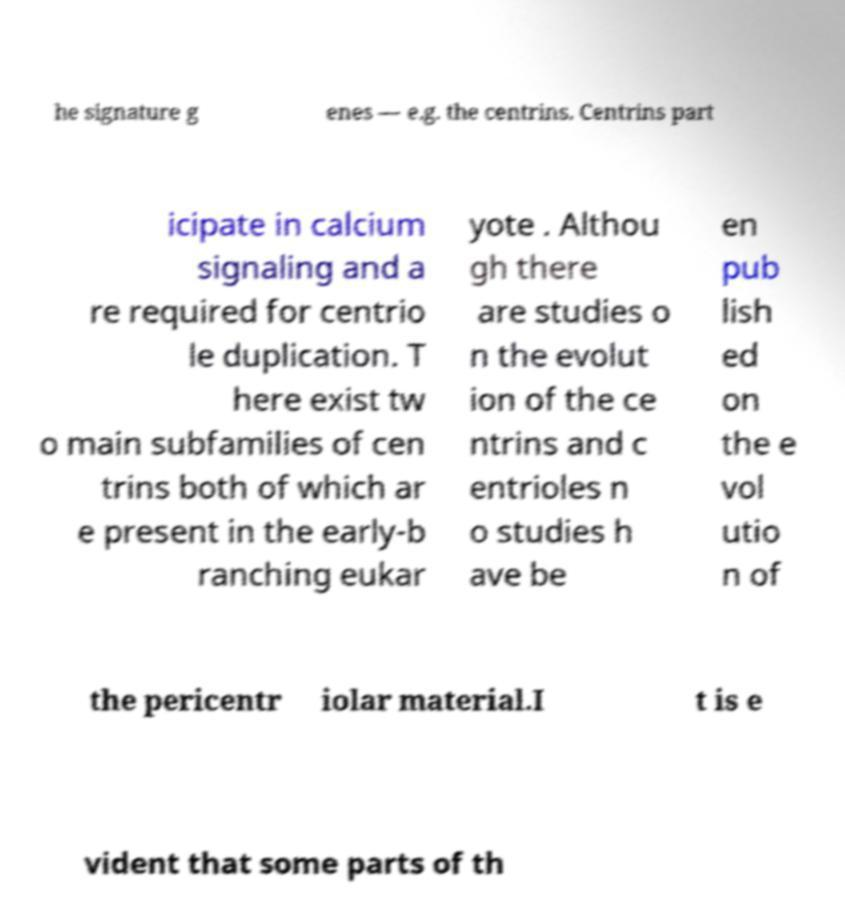There's text embedded in this image that I need extracted. Can you transcribe it verbatim? he signature g enes — e.g. the centrins. Centrins part icipate in calcium signaling and a re required for centrio le duplication. T here exist tw o main subfamilies of cen trins both of which ar e present in the early-b ranching eukar yote . Althou gh there are studies o n the evolut ion of the ce ntrins and c entrioles n o studies h ave be en pub lish ed on the e vol utio n of the pericentr iolar material.I t is e vident that some parts of th 